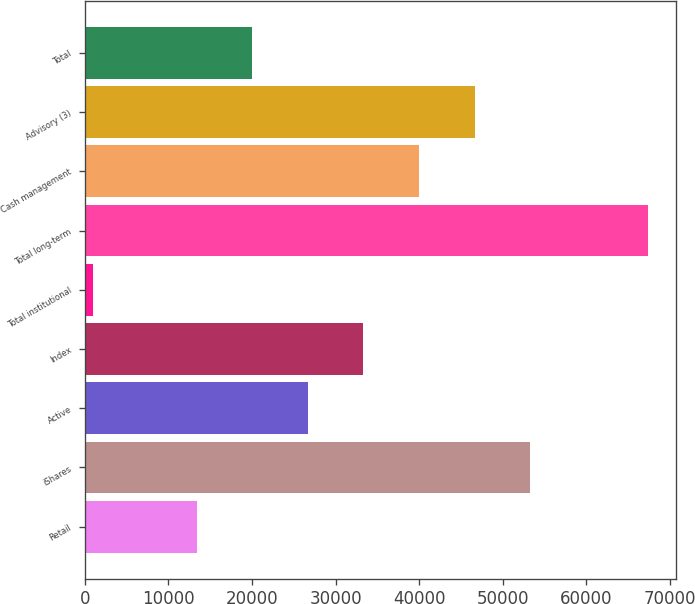Convert chart to OTSL. <chart><loc_0><loc_0><loc_500><loc_500><bar_chart><fcel>Retail<fcel>iShares<fcel>Active<fcel>Index<fcel>Total institutional<fcel>Total long-term<fcel>Cash management<fcel>Advisory (3)<fcel>Total<nl><fcel>13409<fcel>53254.4<fcel>26690.8<fcel>33331.7<fcel>940<fcel>67349<fcel>39972.6<fcel>46613.5<fcel>20049.9<nl></chart> 